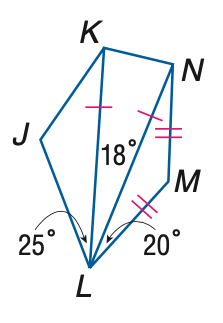Answer the mathemtical geometry problem and directly provide the correct option letter.
Question: \triangle K L N and \triangle L M N are isosceles and m \angle J K N = 130. Find the measure of \angle L N M.
Choices: A: 18 B: 20 C: 21 D: 25 B 